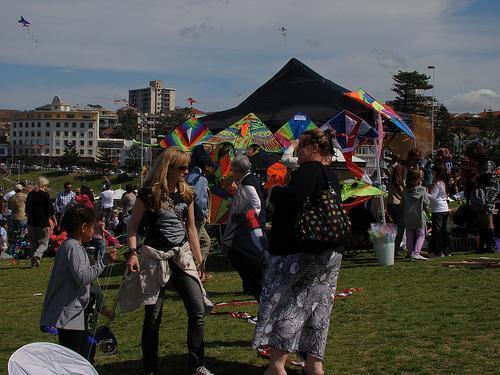How many kites look like a plane?
Give a very brief answer. 1. 